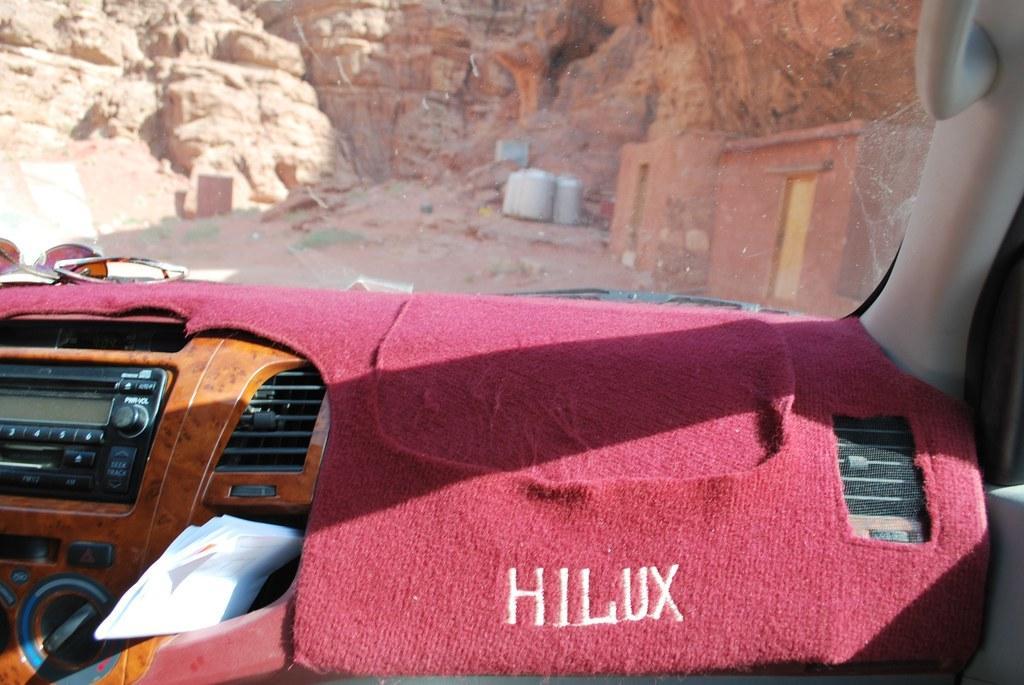In one or two sentences, can you explain what this image depicts? Here in this picture we can see a dashboard of a vehicle and we can also see a music player and knobs and AC ducts and a cloth on it present and in the front we can see a wind shield, through which we can see rocks present and on the right side we can see rooms present. 